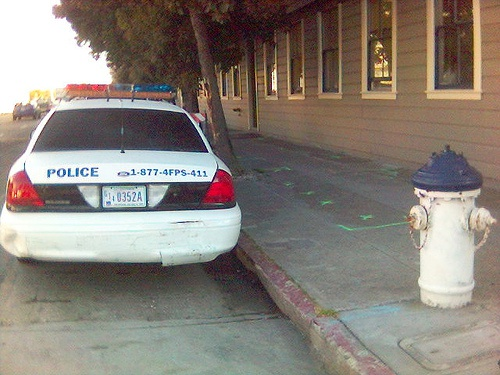Describe the objects in this image and their specific colors. I can see car in white, gray, black, and darkgray tones, fire hydrant in white, ivory, gray, darkgray, and lightgray tones, car in white, darkgray, and gray tones, and car in white, darkgray, tan, and gray tones in this image. 